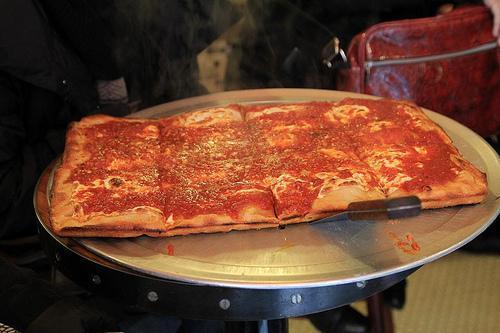How many people are eating bread near the table ?
Give a very brief answer. 0. 